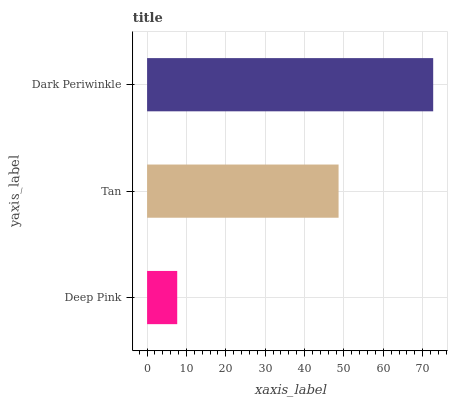Is Deep Pink the minimum?
Answer yes or no. Yes. Is Dark Periwinkle the maximum?
Answer yes or no. Yes. Is Tan the minimum?
Answer yes or no. No. Is Tan the maximum?
Answer yes or no. No. Is Tan greater than Deep Pink?
Answer yes or no. Yes. Is Deep Pink less than Tan?
Answer yes or no. Yes. Is Deep Pink greater than Tan?
Answer yes or no. No. Is Tan less than Deep Pink?
Answer yes or no. No. Is Tan the high median?
Answer yes or no. Yes. Is Tan the low median?
Answer yes or no. Yes. Is Deep Pink the high median?
Answer yes or no. No. Is Deep Pink the low median?
Answer yes or no. No. 